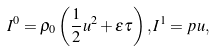<formula> <loc_0><loc_0><loc_500><loc_500>I ^ { 0 } = \rho _ { 0 } \left ( \frac { 1 } { 2 } u ^ { 2 } + \varepsilon \tau \right ) , I ^ { 1 } = p u ,</formula> 